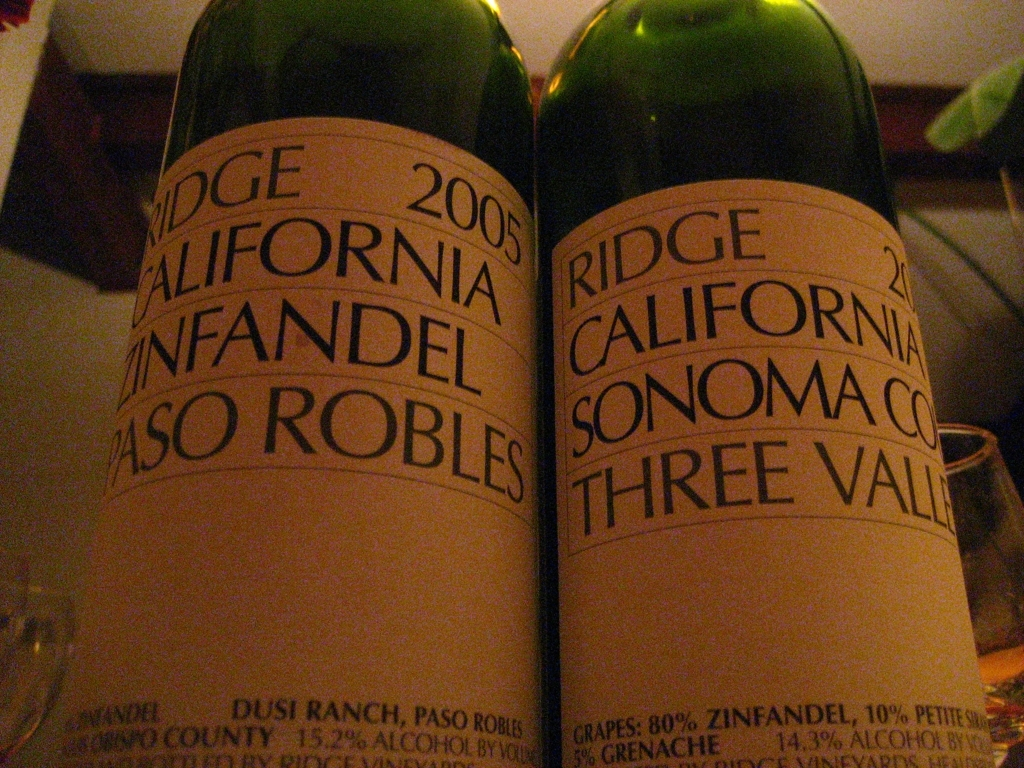What might the taste profile be like for these wines? While we cannot taste through visuals, Zinfandel typically offers a fruit-forward profile with flavors of berry, cherry, as well as notes of spice, tobacco, or oak, depending on the aging process. The blend from Three Valleys suggests complexity with potential berry flavors from Zinfandel, denser notes from Petite Sirah, and possibly some lighter, peppery tones from Grenache. Both being from Ridge, a respected winery, suggests a well-balanced, robust taste experience. 